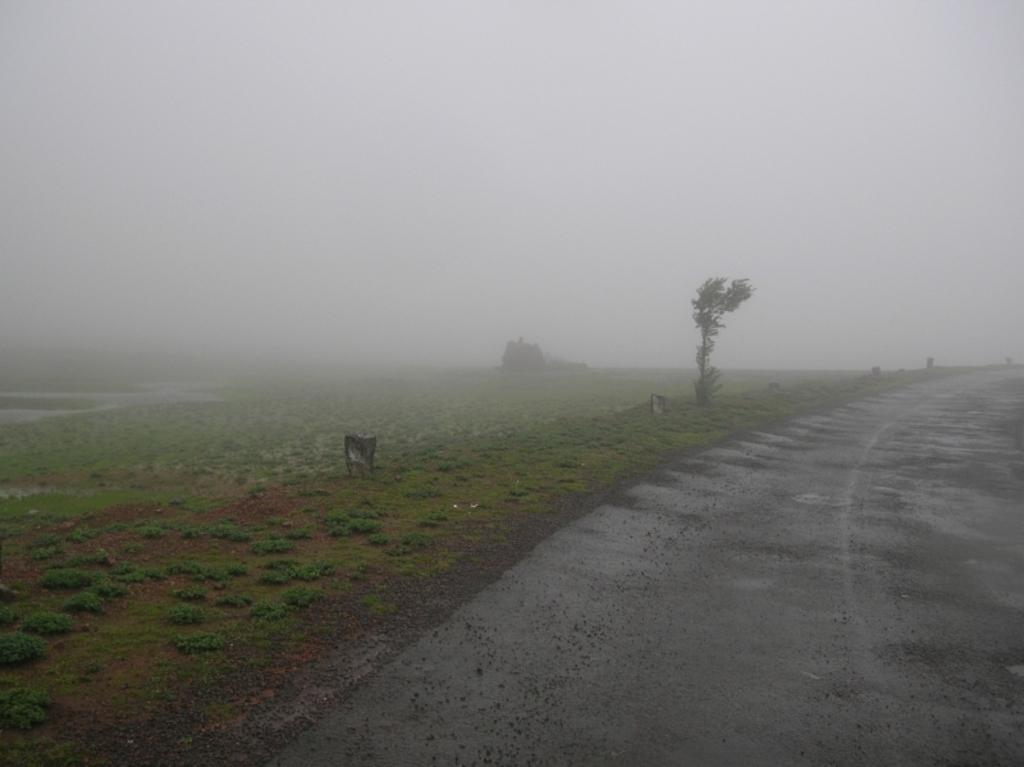What type of vegetation is visible in the image? There is green grass in the image. What type of man-made structure can be seen in the image? There is a road visible in the image. What is visible in the sky in the image? Clouds are present in the sky in the image. What type of machine can be seen creating art in the image? There is no machine present in the image, nor is there any indication of art being created. Who are the friends seen together in the image? There is no reference to friends or any people in the image. 